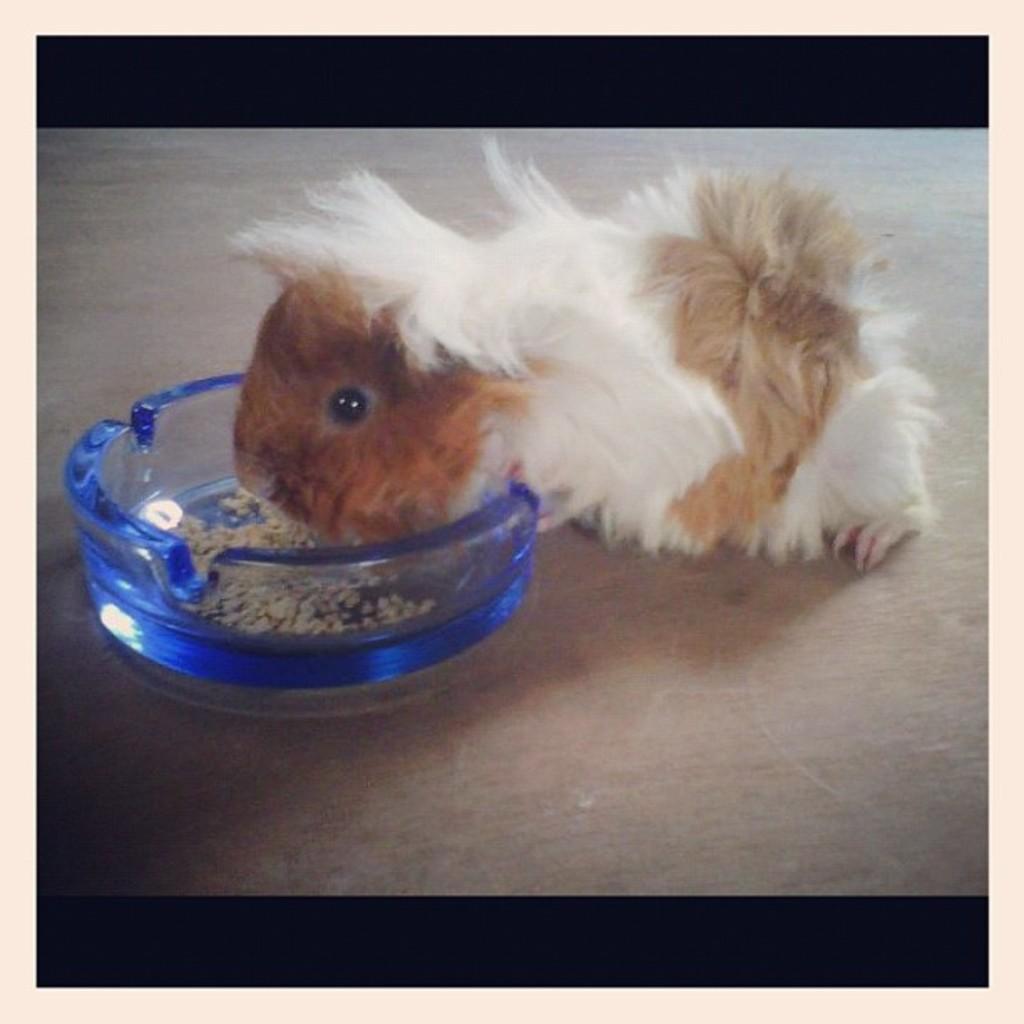In one or two sentences, can you explain what this image depicts? In this picture this is the guinea pig. It is eating something which is in glass bowl. This is the floor. 